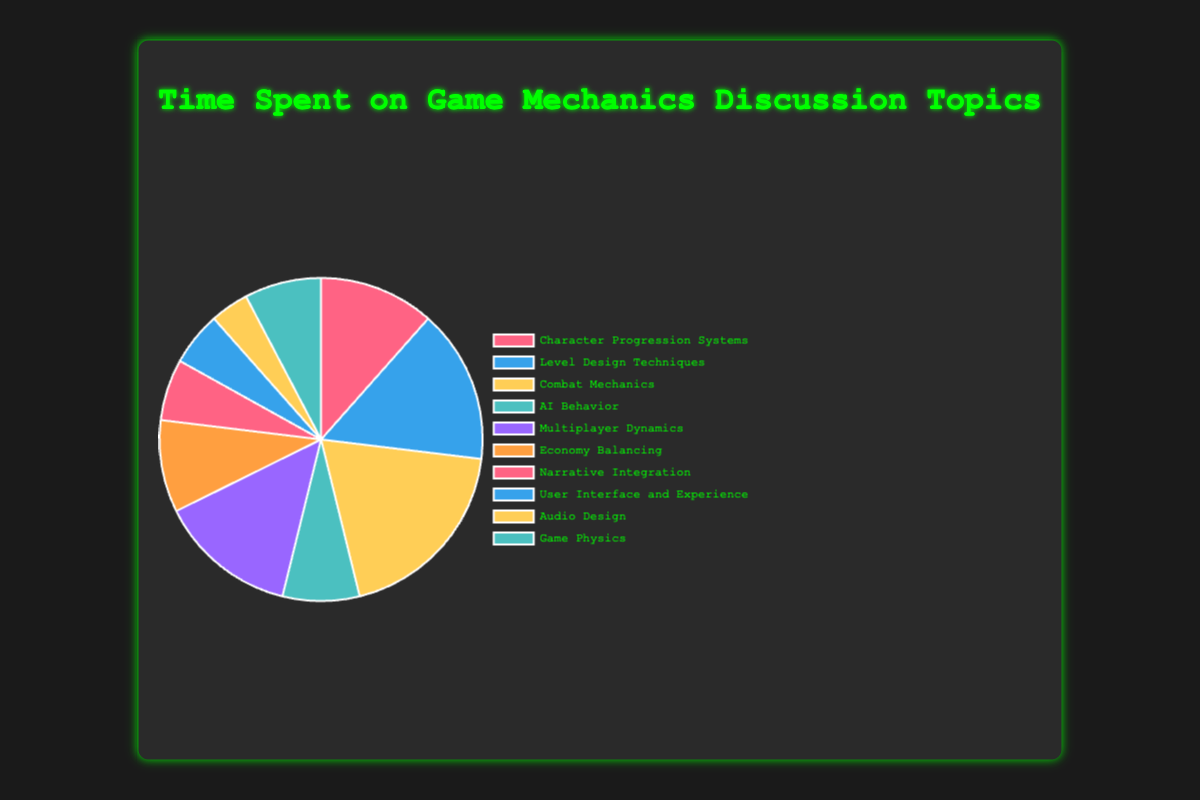Which topic has the highest amount of time spent discussing? By looking at the chart, identify the section representing the largest portion. The "Combat Mechanics" section is the largest.
Answer: Combat Mechanics How many hours in total were spent discussing Combat Mechanics and Level Design Techniques combined? Find the time spent discussing Combat Mechanics (25 hours) and Level Design Techniques (20 hours), then sum them up: 25 + 20.
Answer: 45 What is the least discussed topic? Identify the smallest segment in the pie chart. The "Audio Design" segment is the smallest.
Answer: Audio Design Compare the time spent on Economy Balancing to Narrative Integration. Which one is greater? Look at the segments for "Economy Balancing" (12 hours) and "Narrative Integration" (8 hours). Economy Balancing has more time spent.
Answer: Economy Balancing What is the difference in time spent between Character Progression Systems and AI Behavior? Find the hours for Character Progression Systems (15) and AI Behavior (10), then calculate the difference: 15 - 10.
Answer: 5 What is the total time spent on discussions? Add up the hours for all topics: 15 + 20 + 25 + 10 + 18 + 12 + 8 + 7 + 5 + 10. The sum is 130 hours.
Answer: 130 Which topic has the same amount of discussion time as AI Behavior? Find the segment with the same size as AI Behavior (10 hours). "Game Physics" also has 10 hours.
Answer: Game Physics What percentage of the total discussion time was spent on Multiplayer Dynamics? Calculate the percentage: (18 hours / 130 total hours) * 100. This equals approximately 13.85%.
Answer: ~13.85% How does the time spent on User Interface and Experience compare to the time spent on Audio Design? Identify the hours for both: User Interface and Experience (7) and Audio Design (5). User Interface and Experience has more hours.
Answer: User Interface and Experience Which three topics have the most time spent on discussions? Find the three largest segments: Combat Mechanics (25), Level Design Techniques (20), and Multiplayer Dynamics (18).
Answer: Combat Mechanics, Level Design Techniques, Multiplayer Dynamics 